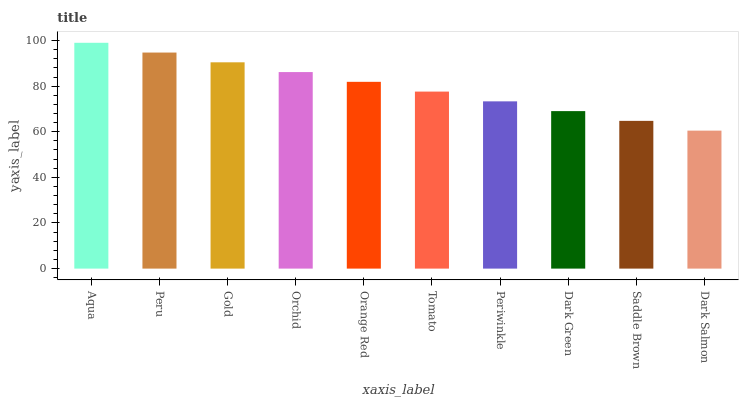Is Dark Salmon the minimum?
Answer yes or no. Yes. Is Aqua the maximum?
Answer yes or no. Yes. Is Peru the minimum?
Answer yes or no. No. Is Peru the maximum?
Answer yes or no. No. Is Aqua greater than Peru?
Answer yes or no. Yes. Is Peru less than Aqua?
Answer yes or no. Yes. Is Peru greater than Aqua?
Answer yes or no. No. Is Aqua less than Peru?
Answer yes or no. No. Is Orange Red the high median?
Answer yes or no. Yes. Is Tomato the low median?
Answer yes or no. Yes. Is Dark Green the high median?
Answer yes or no. No. Is Saddle Brown the low median?
Answer yes or no. No. 